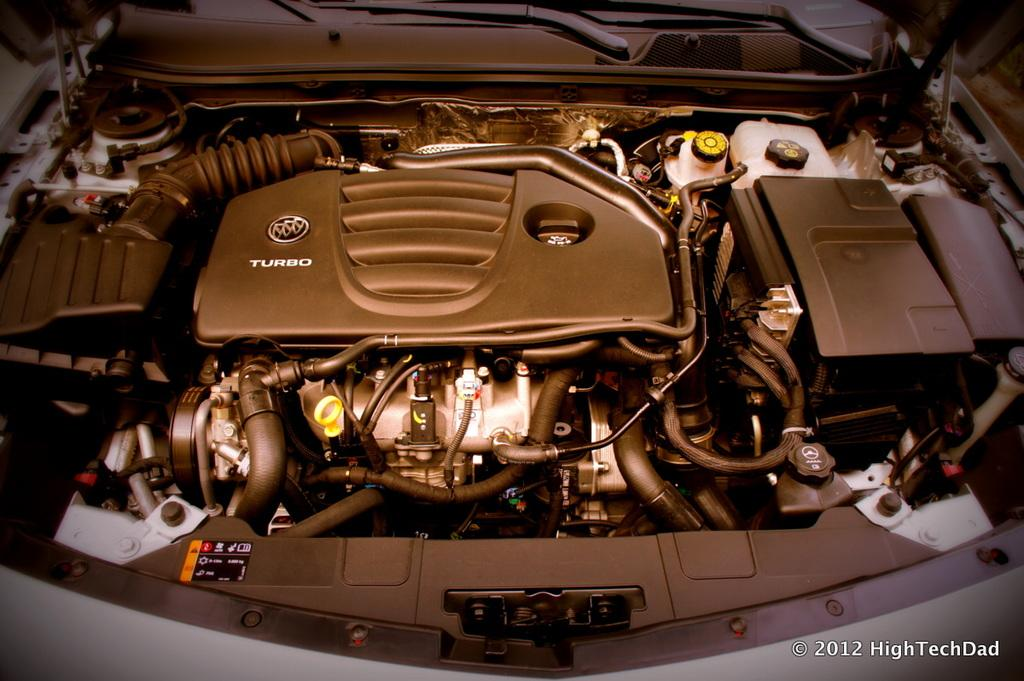<image>
Render a clear and concise summary of the photo. A turbo engine of a car is photographed by high Tech dad. 